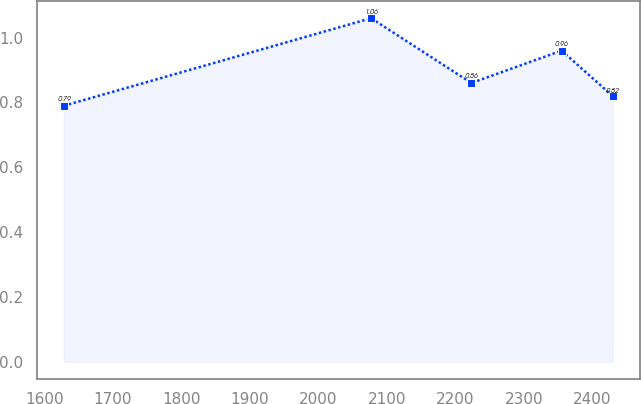Convert chart to OTSL. <chart><loc_0><loc_0><loc_500><loc_500><line_chart><ecel><fcel>Unnamed: 1<nl><fcel>1628.48<fcel>0.79<nl><fcel>2076.78<fcel>1.06<nl><fcel>2223.11<fcel>0.86<nl><fcel>2354.82<fcel>0.96<nl><fcel>2429.29<fcel>0.82<nl></chart> 